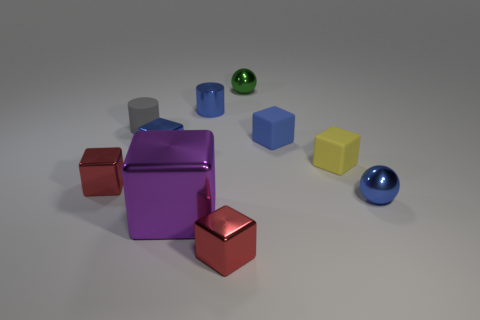How many things are the same color as the small shiny cylinder?
Provide a succinct answer. 3. How many things are either cylinders that are behind the gray matte thing or tiny blue metallic spheres?
Your answer should be compact. 2. Is the big purple cube made of the same material as the tiny sphere left of the yellow matte thing?
Your answer should be very brief. Yes. How many other things are the same shape as the purple shiny thing?
Offer a terse response. 5. What number of objects are either blue metallic spheres that are in front of the gray matte cylinder or small balls that are behind the tiny shiny cylinder?
Make the answer very short. 2. How many other objects are the same color as the small shiny cylinder?
Offer a very short reply. 3. Is the number of metallic balls that are behind the small yellow matte cube less than the number of tiny spheres to the right of the blue rubber object?
Ensure brevity in your answer.  No. What number of yellow objects are there?
Your answer should be very brief. 1. Is there anything else that is made of the same material as the tiny yellow block?
Offer a terse response. Yes. There is a tiny yellow object that is the same shape as the big object; what is it made of?
Your answer should be very brief. Rubber. 